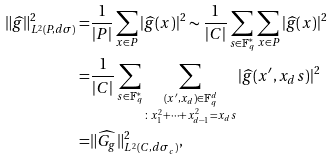<formula> <loc_0><loc_0><loc_500><loc_500>\| \widehat { g } \| ^ { 2 } _ { L ^ { 2 } ( P , d \sigma ) } = & \frac { 1 } { | P | } \sum _ { x \in P } | \widehat { g } ( x ) | ^ { 2 } \sim \frac { 1 } { | C | } \sum _ { s \in \mathbb { F } _ { q } ^ { * } } \sum _ { x \in P } | \widehat { g } ( x ) | ^ { 2 } \\ = & \frac { 1 } { | C | } \sum _ { s \in \mathbb { F } _ { q } ^ { * } } \sum _ { \substack { ( x ^ { \prime } , x _ { d } ) \in \mathbb { F } _ { q } ^ { d } \\ \colon x _ { 1 } ^ { 2 } + \cdots + x _ { d - 1 } ^ { 2 } = x _ { d } s } } | \widehat { g } ( x ^ { \prime } , x _ { d } s ) | ^ { 2 } \\ = & \| \widehat { G _ { g } } \| ^ { 2 } _ { L ^ { 2 } ( C , d \sigma _ { c } ) } ,</formula> 